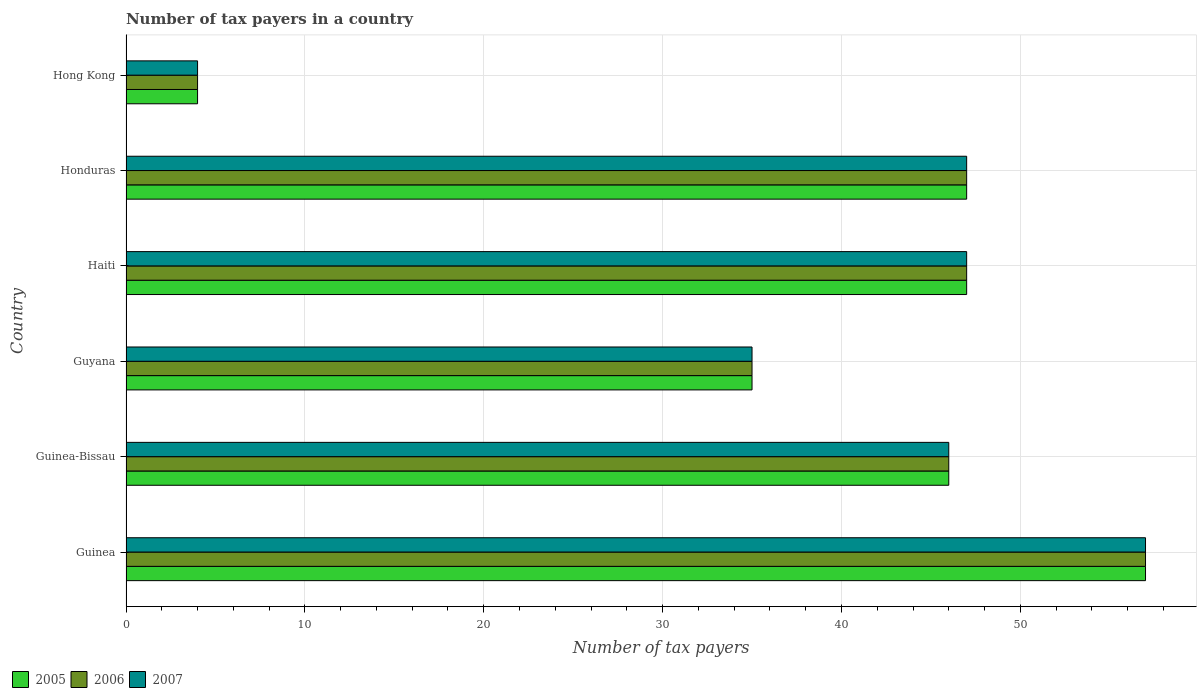How many different coloured bars are there?
Your answer should be very brief. 3. Are the number of bars per tick equal to the number of legend labels?
Offer a terse response. Yes. Are the number of bars on each tick of the Y-axis equal?
Ensure brevity in your answer.  Yes. What is the label of the 6th group of bars from the top?
Offer a terse response. Guinea. In how many cases, is the number of bars for a given country not equal to the number of legend labels?
Offer a very short reply. 0. Across all countries, what is the maximum number of tax payers in in 2005?
Your response must be concise. 57. In which country was the number of tax payers in in 2005 maximum?
Your response must be concise. Guinea. In which country was the number of tax payers in in 2005 minimum?
Ensure brevity in your answer.  Hong Kong. What is the total number of tax payers in in 2006 in the graph?
Offer a terse response. 236. What is the difference between the number of tax payers in in 2007 in Guinea and that in Hong Kong?
Offer a terse response. 53. What is the difference between the number of tax payers in in 2007 in Hong Kong and the number of tax payers in in 2006 in Haiti?
Make the answer very short. -43. What is the average number of tax payers in in 2007 per country?
Your response must be concise. 39.33. What is the difference between the number of tax payers in in 2006 and number of tax payers in in 2007 in Guinea?
Your answer should be compact. 0. What is the difference between the highest and the second highest number of tax payers in in 2006?
Provide a succinct answer. 10. In how many countries, is the number of tax payers in in 2006 greater than the average number of tax payers in in 2006 taken over all countries?
Your answer should be compact. 4. Is the sum of the number of tax payers in in 2005 in Guinea-Bissau and Hong Kong greater than the maximum number of tax payers in in 2007 across all countries?
Provide a short and direct response. No. What does the 2nd bar from the top in Guyana represents?
Your answer should be compact. 2006. What does the 3rd bar from the bottom in Haiti represents?
Keep it short and to the point. 2007. Are the values on the major ticks of X-axis written in scientific E-notation?
Make the answer very short. No. Does the graph contain any zero values?
Make the answer very short. No. How many legend labels are there?
Provide a succinct answer. 3. How are the legend labels stacked?
Offer a terse response. Horizontal. What is the title of the graph?
Your answer should be very brief. Number of tax payers in a country. What is the label or title of the X-axis?
Give a very brief answer. Number of tax payers. What is the label or title of the Y-axis?
Provide a succinct answer. Country. What is the Number of tax payers in 2006 in Guinea?
Offer a very short reply. 57. What is the Number of tax payers in 2007 in Guinea-Bissau?
Provide a short and direct response. 46. What is the Number of tax payers of 2005 in Haiti?
Ensure brevity in your answer.  47. What is the Number of tax payers of 2006 in Haiti?
Provide a short and direct response. 47. What is the Number of tax payers in 2005 in Honduras?
Provide a short and direct response. 47. What is the Number of tax payers in 2007 in Honduras?
Make the answer very short. 47. What is the Number of tax payers in 2007 in Hong Kong?
Provide a short and direct response. 4. Across all countries, what is the maximum Number of tax payers of 2005?
Ensure brevity in your answer.  57. Across all countries, what is the minimum Number of tax payers of 2005?
Ensure brevity in your answer.  4. Across all countries, what is the minimum Number of tax payers of 2007?
Keep it short and to the point. 4. What is the total Number of tax payers of 2005 in the graph?
Your answer should be compact. 236. What is the total Number of tax payers of 2006 in the graph?
Your response must be concise. 236. What is the total Number of tax payers of 2007 in the graph?
Keep it short and to the point. 236. What is the difference between the Number of tax payers in 2005 in Guinea and that in Guinea-Bissau?
Your answer should be very brief. 11. What is the difference between the Number of tax payers of 2007 in Guinea and that in Guinea-Bissau?
Your answer should be very brief. 11. What is the difference between the Number of tax payers of 2006 in Guinea and that in Guyana?
Offer a very short reply. 22. What is the difference between the Number of tax payers of 2006 in Guinea and that in Haiti?
Your answer should be very brief. 10. What is the difference between the Number of tax payers of 2005 in Guinea and that in Honduras?
Give a very brief answer. 10. What is the difference between the Number of tax payers in 2006 in Guinea and that in Honduras?
Give a very brief answer. 10. What is the difference between the Number of tax payers in 2005 in Guinea and that in Hong Kong?
Ensure brevity in your answer.  53. What is the difference between the Number of tax payers of 2005 in Guinea-Bissau and that in Guyana?
Keep it short and to the point. 11. What is the difference between the Number of tax payers of 2007 in Guinea-Bissau and that in Guyana?
Ensure brevity in your answer.  11. What is the difference between the Number of tax payers in 2005 in Guinea-Bissau and that in Haiti?
Give a very brief answer. -1. What is the difference between the Number of tax payers in 2007 in Guinea-Bissau and that in Haiti?
Give a very brief answer. -1. What is the difference between the Number of tax payers of 2006 in Guinea-Bissau and that in Honduras?
Make the answer very short. -1. What is the difference between the Number of tax payers of 2005 in Guyana and that in Haiti?
Your answer should be very brief. -12. What is the difference between the Number of tax payers of 2006 in Guyana and that in Honduras?
Provide a succinct answer. -12. What is the difference between the Number of tax payers in 2005 in Guyana and that in Hong Kong?
Provide a succinct answer. 31. What is the difference between the Number of tax payers of 2007 in Guyana and that in Hong Kong?
Offer a terse response. 31. What is the difference between the Number of tax payers of 2007 in Haiti and that in Hong Kong?
Your response must be concise. 43. What is the difference between the Number of tax payers in 2005 in Honduras and that in Hong Kong?
Offer a terse response. 43. What is the difference between the Number of tax payers of 2005 in Guinea and the Number of tax payers of 2007 in Guyana?
Your answer should be compact. 22. What is the difference between the Number of tax payers of 2005 in Guinea and the Number of tax payers of 2006 in Haiti?
Your answer should be compact. 10. What is the difference between the Number of tax payers of 2005 in Guinea and the Number of tax payers of 2007 in Haiti?
Offer a terse response. 10. What is the difference between the Number of tax payers of 2006 in Guinea and the Number of tax payers of 2007 in Haiti?
Your answer should be very brief. 10. What is the difference between the Number of tax payers of 2005 in Guinea and the Number of tax payers of 2007 in Hong Kong?
Your answer should be compact. 53. What is the difference between the Number of tax payers of 2006 in Guinea and the Number of tax payers of 2007 in Hong Kong?
Ensure brevity in your answer.  53. What is the difference between the Number of tax payers of 2005 in Guinea-Bissau and the Number of tax payers of 2007 in Guyana?
Offer a very short reply. 11. What is the difference between the Number of tax payers in 2006 in Guinea-Bissau and the Number of tax payers in 2007 in Guyana?
Make the answer very short. 11. What is the difference between the Number of tax payers in 2005 in Guinea-Bissau and the Number of tax payers in 2006 in Haiti?
Give a very brief answer. -1. What is the difference between the Number of tax payers in 2005 in Guinea-Bissau and the Number of tax payers in 2007 in Honduras?
Offer a terse response. -1. What is the difference between the Number of tax payers of 2006 in Guinea-Bissau and the Number of tax payers of 2007 in Honduras?
Your response must be concise. -1. What is the difference between the Number of tax payers in 2005 in Guinea-Bissau and the Number of tax payers in 2007 in Hong Kong?
Keep it short and to the point. 42. What is the difference between the Number of tax payers of 2006 in Guinea-Bissau and the Number of tax payers of 2007 in Hong Kong?
Your answer should be very brief. 42. What is the difference between the Number of tax payers in 2005 in Guyana and the Number of tax payers in 2007 in Honduras?
Your answer should be compact. -12. What is the difference between the Number of tax payers in 2005 in Guyana and the Number of tax payers in 2006 in Hong Kong?
Keep it short and to the point. 31. What is the difference between the Number of tax payers of 2005 in Guyana and the Number of tax payers of 2007 in Hong Kong?
Your answer should be compact. 31. What is the difference between the Number of tax payers of 2006 in Guyana and the Number of tax payers of 2007 in Hong Kong?
Provide a succinct answer. 31. What is the difference between the Number of tax payers in 2005 in Haiti and the Number of tax payers in 2007 in Honduras?
Your response must be concise. 0. What is the difference between the Number of tax payers of 2006 in Haiti and the Number of tax payers of 2007 in Honduras?
Ensure brevity in your answer.  0. What is the difference between the Number of tax payers of 2006 in Haiti and the Number of tax payers of 2007 in Hong Kong?
Ensure brevity in your answer.  43. What is the difference between the Number of tax payers of 2006 in Honduras and the Number of tax payers of 2007 in Hong Kong?
Provide a succinct answer. 43. What is the average Number of tax payers in 2005 per country?
Provide a succinct answer. 39.33. What is the average Number of tax payers in 2006 per country?
Offer a terse response. 39.33. What is the average Number of tax payers in 2007 per country?
Your answer should be very brief. 39.33. What is the difference between the Number of tax payers in 2005 and Number of tax payers in 2007 in Guinea?
Your answer should be very brief. 0. What is the difference between the Number of tax payers of 2006 and Number of tax payers of 2007 in Guinea?
Provide a succinct answer. 0. What is the difference between the Number of tax payers in 2005 and Number of tax payers in 2007 in Guinea-Bissau?
Keep it short and to the point. 0. What is the difference between the Number of tax payers of 2006 and Number of tax payers of 2007 in Guinea-Bissau?
Your answer should be compact. 0. What is the difference between the Number of tax payers in 2005 and Number of tax payers in 2007 in Haiti?
Keep it short and to the point. 0. What is the difference between the Number of tax payers in 2006 and Number of tax payers in 2007 in Haiti?
Offer a very short reply. 0. What is the difference between the Number of tax payers in 2005 and Number of tax payers in 2006 in Honduras?
Keep it short and to the point. 0. What is the difference between the Number of tax payers in 2006 and Number of tax payers in 2007 in Honduras?
Ensure brevity in your answer.  0. What is the difference between the Number of tax payers in 2005 and Number of tax payers in 2006 in Hong Kong?
Ensure brevity in your answer.  0. What is the difference between the Number of tax payers of 2006 and Number of tax payers of 2007 in Hong Kong?
Your response must be concise. 0. What is the ratio of the Number of tax payers of 2005 in Guinea to that in Guinea-Bissau?
Keep it short and to the point. 1.24. What is the ratio of the Number of tax payers in 2006 in Guinea to that in Guinea-Bissau?
Your response must be concise. 1.24. What is the ratio of the Number of tax payers in 2007 in Guinea to that in Guinea-Bissau?
Offer a terse response. 1.24. What is the ratio of the Number of tax payers of 2005 in Guinea to that in Guyana?
Provide a short and direct response. 1.63. What is the ratio of the Number of tax payers in 2006 in Guinea to that in Guyana?
Offer a terse response. 1.63. What is the ratio of the Number of tax payers of 2007 in Guinea to that in Guyana?
Provide a short and direct response. 1.63. What is the ratio of the Number of tax payers of 2005 in Guinea to that in Haiti?
Offer a very short reply. 1.21. What is the ratio of the Number of tax payers of 2006 in Guinea to that in Haiti?
Offer a terse response. 1.21. What is the ratio of the Number of tax payers of 2007 in Guinea to that in Haiti?
Your response must be concise. 1.21. What is the ratio of the Number of tax payers of 2005 in Guinea to that in Honduras?
Ensure brevity in your answer.  1.21. What is the ratio of the Number of tax payers of 2006 in Guinea to that in Honduras?
Your answer should be compact. 1.21. What is the ratio of the Number of tax payers of 2007 in Guinea to that in Honduras?
Give a very brief answer. 1.21. What is the ratio of the Number of tax payers in 2005 in Guinea to that in Hong Kong?
Your answer should be very brief. 14.25. What is the ratio of the Number of tax payers of 2006 in Guinea to that in Hong Kong?
Offer a terse response. 14.25. What is the ratio of the Number of tax payers in 2007 in Guinea to that in Hong Kong?
Keep it short and to the point. 14.25. What is the ratio of the Number of tax payers in 2005 in Guinea-Bissau to that in Guyana?
Provide a short and direct response. 1.31. What is the ratio of the Number of tax payers in 2006 in Guinea-Bissau to that in Guyana?
Offer a very short reply. 1.31. What is the ratio of the Number of tax payers in 2007 in Guinea-Bissau to that in Guyana?
Give a very brief answer. 1.31. What is the ratio of the Number of tax payers in 2005 in Guinea-Bissau to that in Haiti?
Offer a very short reply. 0.98. What is the ratio of the Number of tax payers in 2006 in Guinea-Bissau to that in Haiti?
Your answer should be compact. 0.98. What is the ratio of the Number of tax payers of 2007 in Guinea-Bissau to that in Haiti?
Keep it short and to the point. 0.98. What is the ratio of the Number of tax payers of 2005 in Guinea-Bissau to that in Honduras?
Offer a very short reply. 0.98. What is the ratio of the Number of tax payers of 2006 in Guinea-Bissau to that in Honduras?
Offer a very short reply. 0.98. What is the ratio of the Number of tax payers in 2007 in Guinea-Bissau to that in Honduras?
Keep it short and to the point. 0.98. What is the ratio of the Number of tax payers in 2005 in Guinea-Bissau to that in Hong Kong?
Keep it short and to the point. 11.5. What is the ratio of the Number of tax payers of 2006 in Guinea-Bissau to that in Hong Kong?
Provide a short and direct response. 11.5. What is the ratio of the Number of tax payers of 2005 in Guyana to that in Haiti?
Provide a succinct answer. 0.74. What is the ratio of the Number of tax payers of 2006 in Guyana to that in Haiti?
Your response must be concise. 0.74. What is the ratio of the Number of tax payers in 2007 in Guyana to that in Haiti?
Provide a short and direct response. 0.74. What is the ratio of the Number of tax payers in 2005 in Guyana to that in Honduras?
Give a very brief answer. 0.74. What is the ratio of the Number of tax payers of 2006 in Guyana to that in Honduras?
Provide a succinct answer. 0.74. What is the ratio of the Number of tax payers of 2007 in Guyana to that in Honduras?
Your answer should be very brief. 0.74. What is the ratio of the Number of tax payers of 2005 in Guyana to that in Hong Kong?
Give a very brief answer. 8.75. What is the ratio of the Number of tax payers of 2006 in Guyana to that in Hong Kong?
Ensure brevity in your answer.  8.75. What is the ratio of the Number of tax payers in 2007 in Guyana to that in Hong Kong?
Your response must be concise. 8.75. What is the ratio of the Number of tax payers in 2005 in Haiti to that in Honduras?
Your answer should be compact. 1. What is the ratio of the Number of tax payers of 2005 in Haiti to that in Hong Kong?
Offer a very short reply. 11.75. What is the ratio of the Number of tax payers in 2006 in Haiti to that in Hong Kong?
Offer a very short reply. 11.75. What is the ratio of the Number of tax payers of 2007 in Haiti to that in Hong Kong?
Your answer should be very brief. 11.75. What is the ratio of the Number of tax payers of 2005 in Honduras to that in Hong Kong?
Keep it short and to the point. 11.75. What is the ratio of the Number of tax payers of 2006 in Honduras to that in Hong Kong?
Make the answer very short. 11.75. What is the ratio of the Number of tax payers in 2007 in Honduras to that in Hong Kong?
Provide a succinct answer. 11.75. What is the difference between the highest and the second highest Number of tax payers in 2005?
Give a very brief answer. 10. What is the difference between the highest and the second highest Number of tax payers in 2006?
Provide a short and direct response. 10. What is the difference between the highest and the second highest Number of tax payers of 2007?
Your response must be concise. 10. What is the difference between the highest and the lowest Number of tax payers in 2006?
Your response must be concise. 53. What is the difference between the highest and the lowest Number of tax payers of 2007?
Give a very brief answer. 53. 